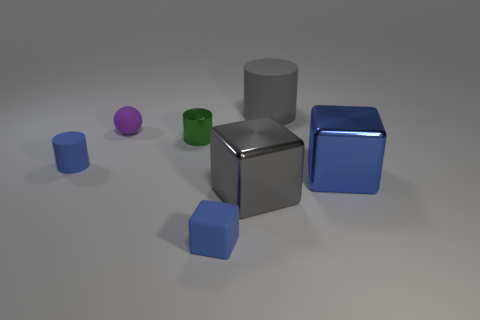There is another large thing that is the same shape as the green metal thing; what is its material?
Ensure brevity in your answer.  Rubber. There is a blue cube that is to the left of the blue block behind the rubber cube; what is its size?
Your response must be concise. Small. Is there a small green thing?
Make the answer very short. Yes. What material is the cylinder that is in front of the tiny purple ball and to the right of the purple thing?
Your response must be concise. Metal. Is the number of big gray matte things that are right of the big gray metal thing greater than the number of large things that are in front of the green thing?
Your response must be concise. No. Are there any blocks that have the same size as the blue metal thing?
Provide a succinct answer. Yes. There is a blue matte object in front of the rubber cylinder on the left side of the big rubber object that is behind the gray shiny block; what is its size?
Provide a succinct answer. Small. The large matte object is what color?
Offer a very short reply. Gray. Is the number of green cylinders that are left of the tiny matte sphere greater than the number of blue cylinders?
Provide a short and direct response. No. What number of large blue blocks are to the right of the small blue rubber cube?
Give a very brief answer. 1. 